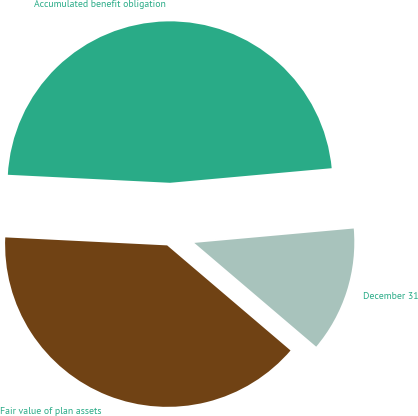Convert chart to OTSL. <chart><loc_0><loc_0><loc_500><loc_500><pie_chart><fcel>December 31<fcel>Accumulated benefit obligation<fcel>Fair value of plan assets<nl><fcel>12.66%<fcel>47.78%<fcel>39.56%<nl></chart> 